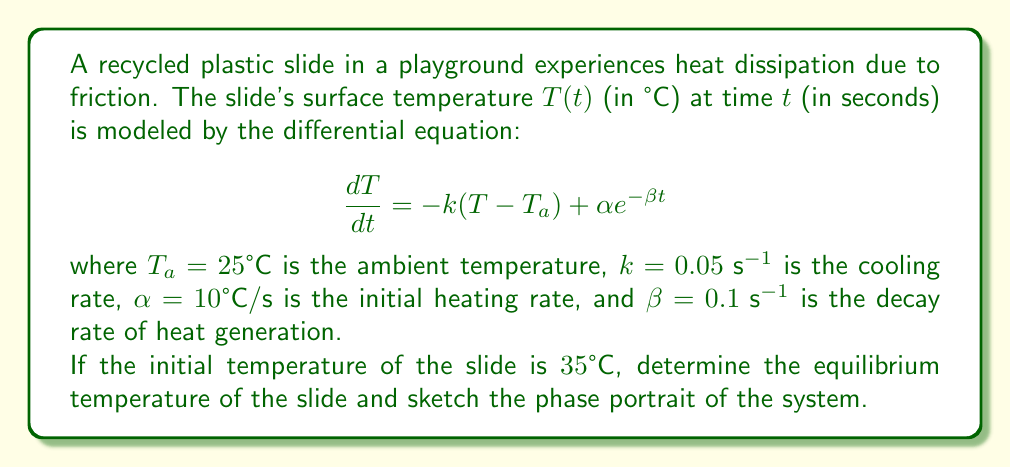Help me with this question. To solve this problem, we'll follow these steps:

1) Find the equilibrium temperature:
   At equilibrium, $\frac{dT}{dt} = 0$. So we solve:
   
   $$0 = -k(T_{eq} - T_a) + \alpha e^{-\beta t}$$
   
   As $t \to \infty$, $e^{-\beta t} \to 0$, so:
   
   $$0 = -k(T_{eq} - T_a)$$
   $$T_{eq} = T_a = 25°C$$

2) Analyze the phase portrait:
   Let's rewrite the equation as:
   
   $$\frac{dT}{dt} = f(T,t) = -k(T - T_a) + \alpha e^{-\beta t}$$
   
   This is a non-autonomous system as it explicitly depends on t.

3) Sketch the phase portrait:
   We can visualize this in the T-t plane:

[asy]
import graph;
size(200,150);
real f(real x, real t) {return -0.05*(x-25) + 10*exp(-0.1*t);}
for(int i=0; i<=10; ++i) {
  guide g;
  for(real t=0; t<=10; t+=0.1) {
    real x = 25 + i*2;
    g = g--(t, f(x,t));
  }
  draw(g, Arrow);
}
xaxis("t", Arrow);
yaxis("dT/dt", Arrow);
label("T=25°C", (10,0), E);
[/asy]

   The phase portrait shows that all trajectories eventually converge to the equilibrium line T = 25°C as t increases.

4) Interpret the results:
   - The equilibrium temperature is the same as the ambient temperature (25°C).
   - The phase portrait shows that regardless of the initial temperature, the system will always tend towards the equilibrium temperature as time progresses.
   - The rate of change (dT/dt) is initially positive for temperatures below 25°C and negative for temperatures above 25°C, driving the system towards equilibrium.
   - As time increases, the effect of the heat generation term (αe^(-βt)) diminishes, and the system is dominated by the cooling term (-k(T-T_a)).
Answer: Equilibrium temperature: 25°C. Phase portrait: converges to T = 25°C as t → ∞. 